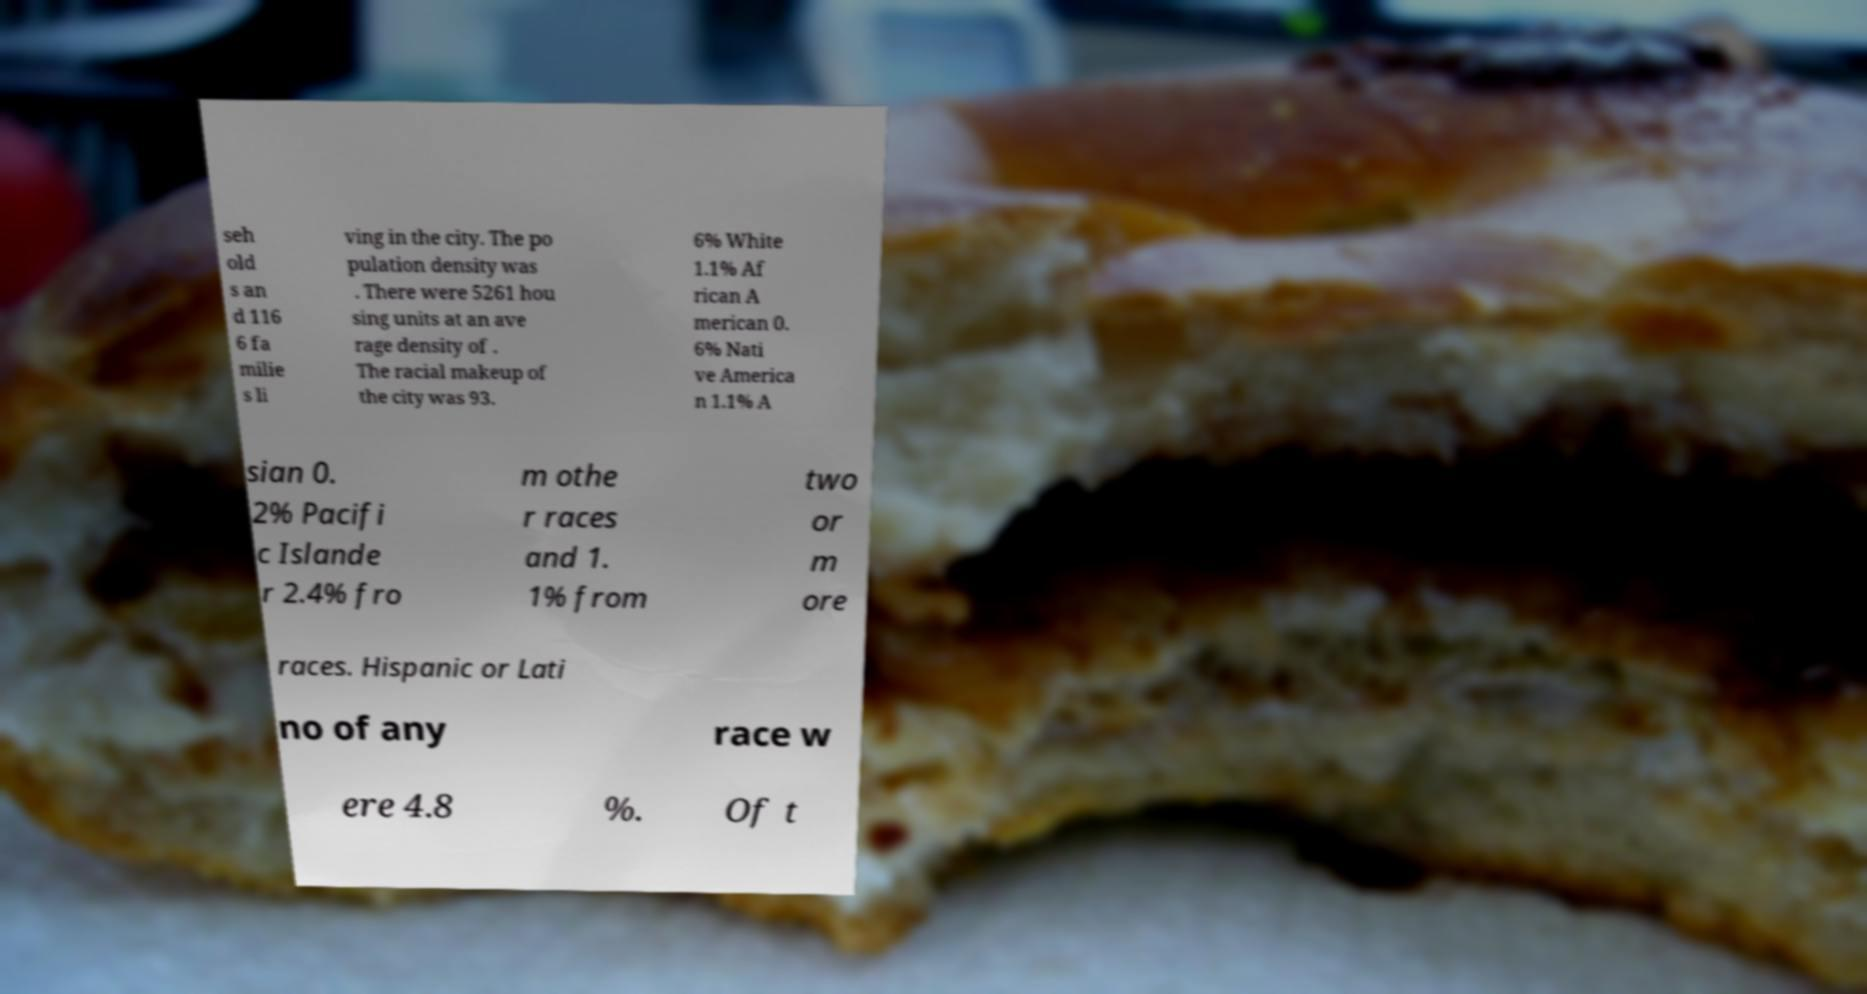Can you accurately transcribe the text from the provided image for me? seh old s an d 116 6 fa milie s li ving in the city. The po pulation density was . There were 5261 hou sing units at an ave rage density of . The racial makeup of the city was 93. 6% White 1.1% Af rican A merican 0. 6% Nati ve America n 1.1% A sian 0. 2% Pacifi c Islande r 2.4% fro m othe r races and 1. 1% from two or m ore races. Hispanic or Lati no of any race w ere 4.8 %. Of t 